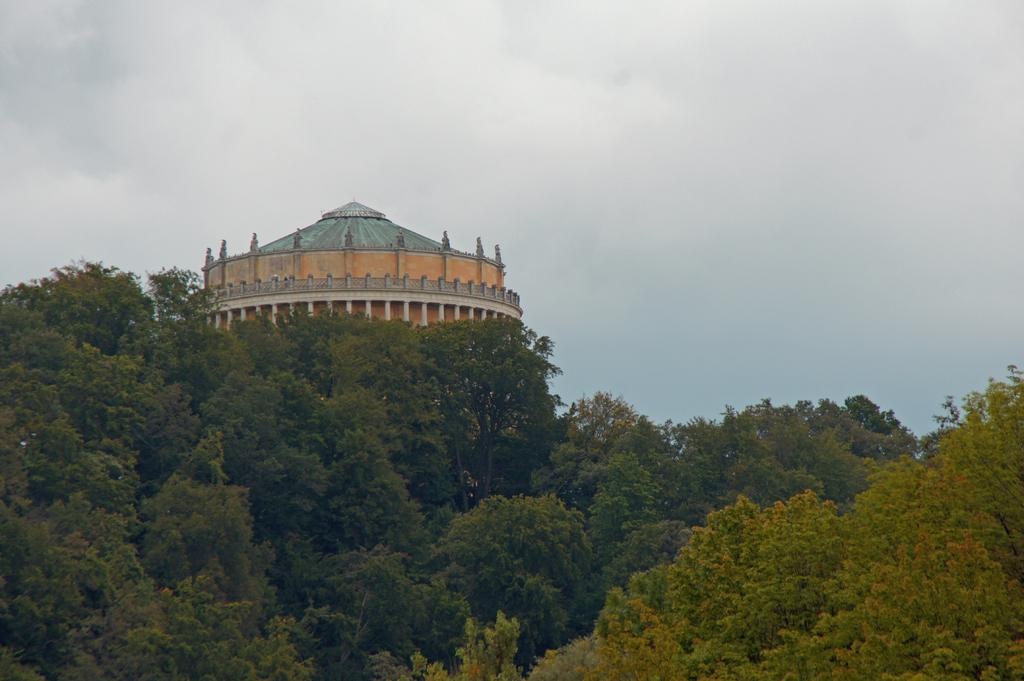What type of vegetation can be seen at the bottom of the image? Trees are present at the bottom of the image. What structure is visible in the background of the image? There is a water tower in the background of the image. What is visible at the top of the image? The sky is visible at the top of the image. What type of wool is being used to make the wind turbines in the image? There are no wind turbines present in the image, so it is not possible to determine what type of wool might be used. 